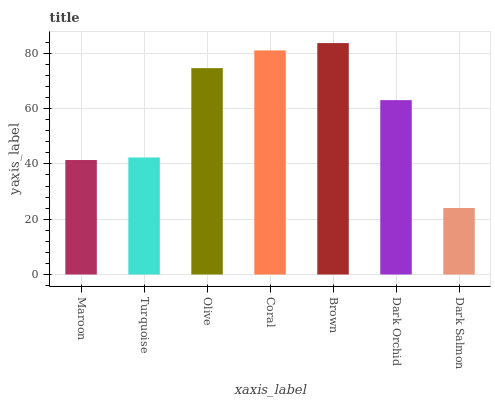Is Dark Salmon the minimum?
Answer yes or no. Yes. Is Brown the maximum?
Answer yes or no. Yes. Is Turquoise the minimum?
Answer yes or no. No. Is Turquoise the maximum?
Answer yes or no. No. Is Turquoise greater than Maroon?
Answer yes or no. Yes. Is Maroon less than Turquoise?
Answer yes or no. Yes. Is Maroon greater than Turquoise?
Answer yes or no. No. Is Turquoise less than Maroon?
Answer yes or no. No. Is Dark Orchid the high median?
Answer yes or no. Yes. Is Dark Orchid the low median?
Answer yes or no. Yes. Is Olive the high median?
Answer yes or no. No. Is Dark Salmon the low median?
Answer yes or no. No. 